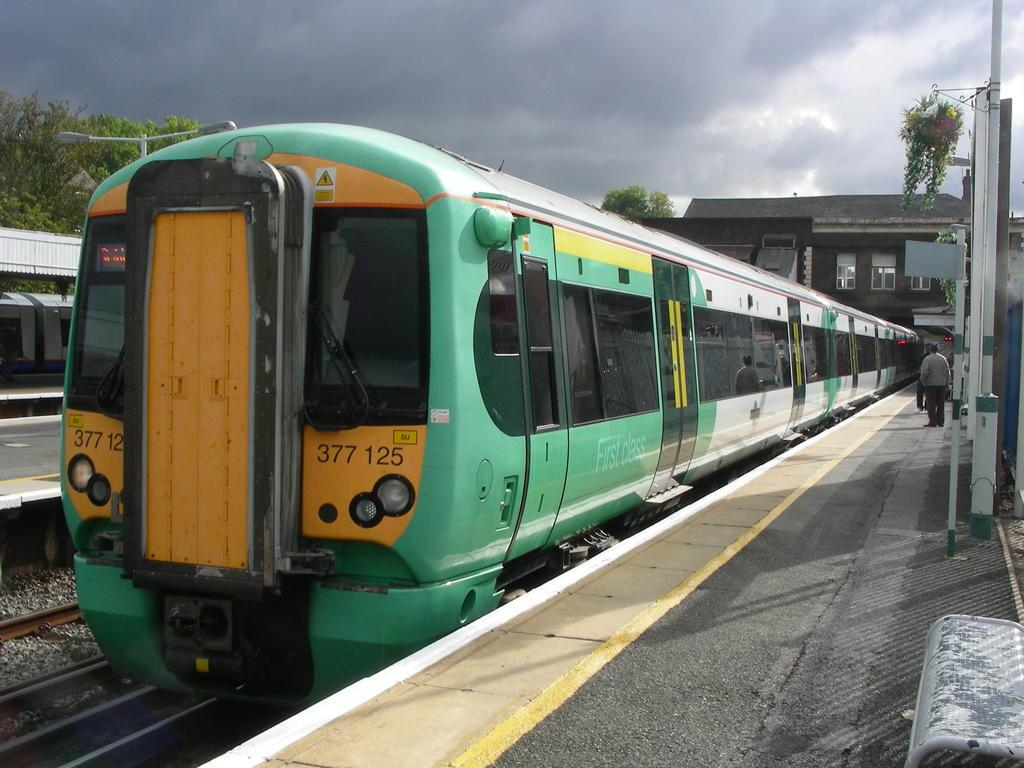<image>
Describe the image concisely. Green and yellow train which says "377125" on it. 